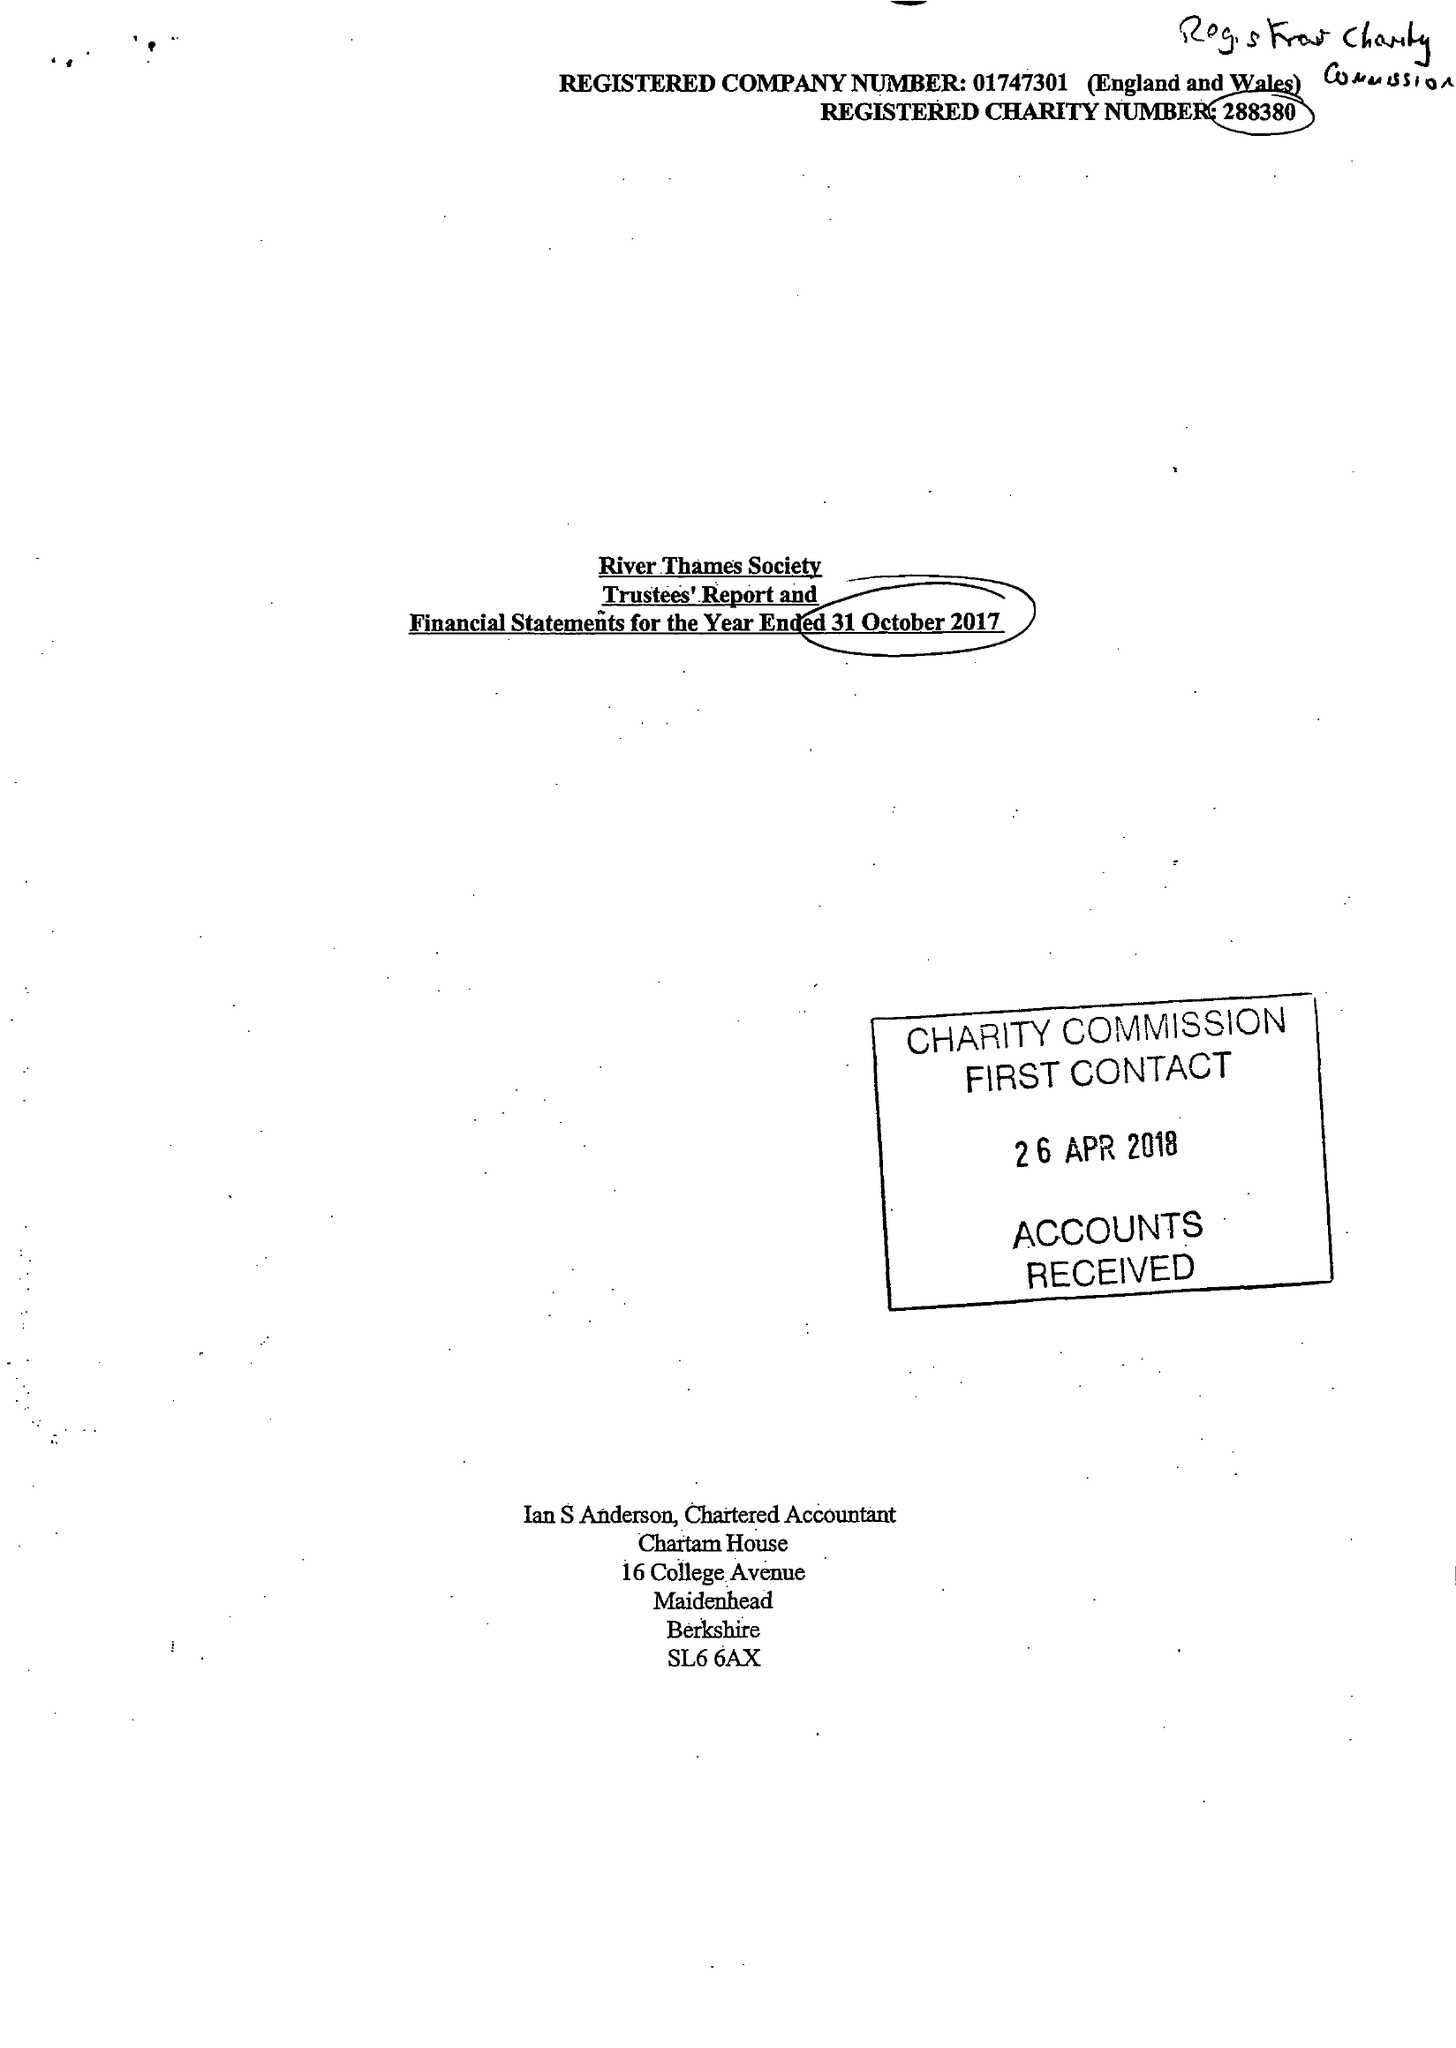What is the value for the report_date?
Answer the question using a single word or phrase. 2017-10-31 